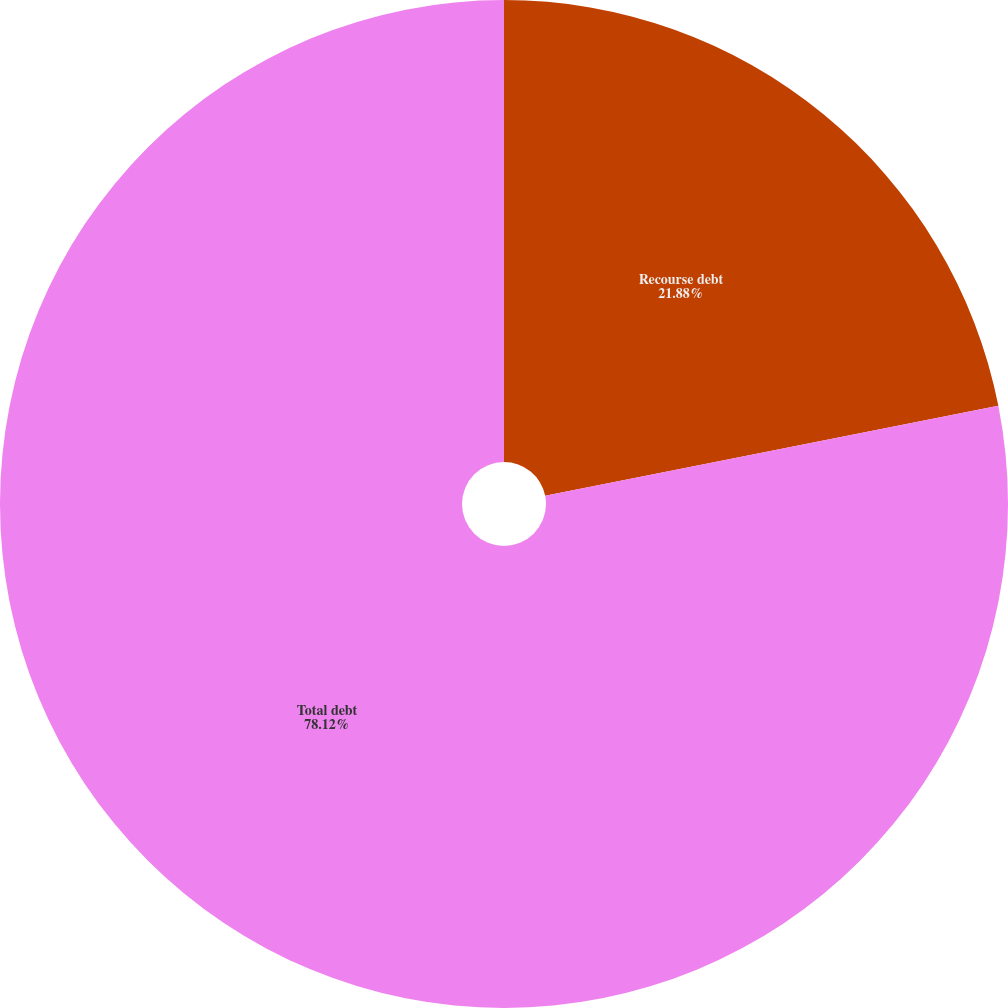<chart> <loc_0><loc_0><loc_500><loc_500><pie_chart><fcel>Recourse debt<fcel>Total debt<nl><fcel>21.88%<fcel>78.12%<nl></chart> 